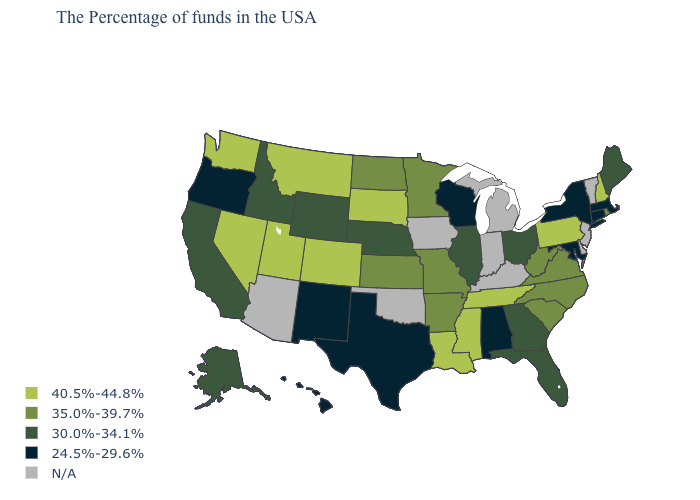How many symbols are there in the legend?
Quick response, please. 5. Which states have the lowest value in the South?
Give a very brief answer. Maryland, Alabama, Texas. Does the map have missing data?
Keep it brief. Yes. What is the value of Minnesota?
Be succinct. 35.0%-39.7%. How many symbols are there in the legend?
Keep it brief. 5. Among the states that border North Dakota , does Minnesota have the lowest value?
Short answer required. Yes. What is the highest value in the MidWest ?
Short answer required. 40.5%-44.8%. What is the value of Wyoming?
Keep it brief. 30.0%-34.1%. What is the highest value in states that border Louisiana?
Concise answer only. 40.5%-44.8%. What is the lowest value in the USA?
Concise answer only. 24.5%-29.6%. Is the legend a continuous bar?
Be succinct. No. Does Oregon have the lowest value in the USA?
Be succinct. Yes. What is the value of Alaska?
Give a very brief answer. 30.0%-34.1%. 